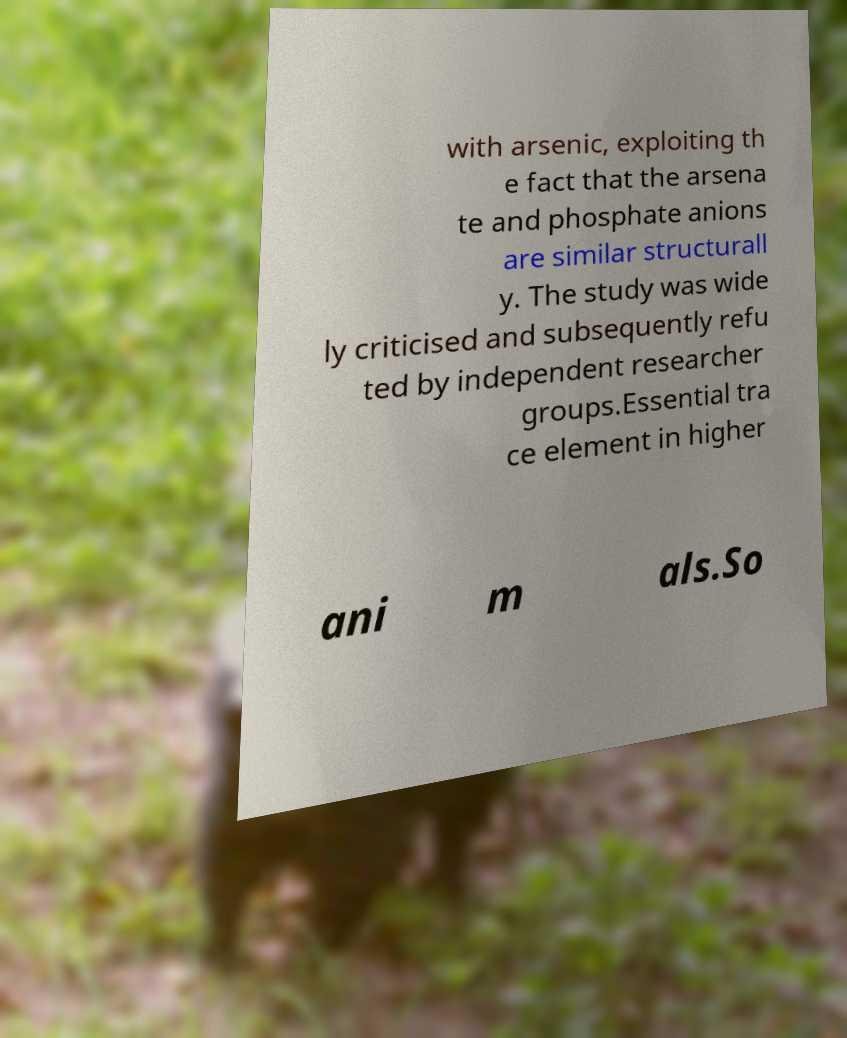Could you extract and type out the text from this image? with arsenic, exploiting th e fact that the arsena te and phosphate anions are similar structurall y. The study was wide ly criticised and subsequently refu ted by independent researcher groups.Essential tra ce element in higher ani m als.So 